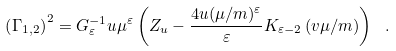<formula> <loc_0><loc_0><loc_500><loc_500>\left ( \Gamma _ { 1 , 2 } \right ) ^ { 2 } = G _ { \varepsilon } ^ { - 1 } u \mu ^ { \varepsilon } \left ( Z _ { u } - \frac { 4 u ( \mu / m ) ^ { \varepsilon } } { \varepsilon } K _ { \varepsilon - 2 } \left ( v \mu / m \right ) \right ) \ .</formula> 